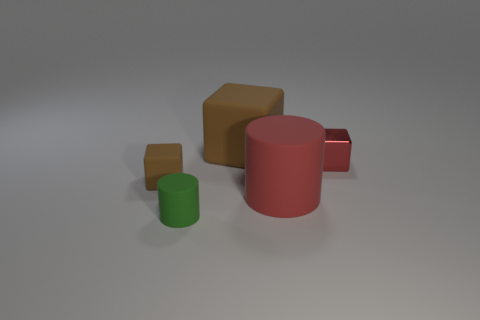Is there another small thing that has the same shape as the red shiny object?
Your answer should be very brief. Yes. There is a red shiny object that is behind the small green matte object; what shape is it?
Provide a short and direct response. Cube. How many matte cubes are right of the brown thing that is left of the brown rubber block that is behind the tiny red object?
Ensure brevity in your answer.  1. Is the color of the small cube to the left of the tiny red metallic block the same as the big cube?
Provide a short and direct response. Yes. How many other objects are there of the same shape as the green rubber object?
Ensure brevity in your answer.  1. How many other objects are there of the same material as the large brown block?
Your answer should be very brief. 3. There is a tiny block that is behind the brown block in front of the brown matte cube that is to the right of the small matte cube; what is it made of?
Your response must be concise. Metal. Is the large cube made of the same material as the large red cylinder?
Keep it short and to the point. Yes. How many cylinders are small matte things or tiny green objects?
Make the answer very short. 1. There is a matte cylinder that is in front of the large red matte cylinder; what color is it?
Your response must be concise. Green. 